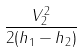<formula> <loc_0><loc_0><loc_500><loc_500>\frac { V _ { 2 } ^ { 2 } } { 2 ( h _ { 1 } - h _ { 2 } ) }</formula> 